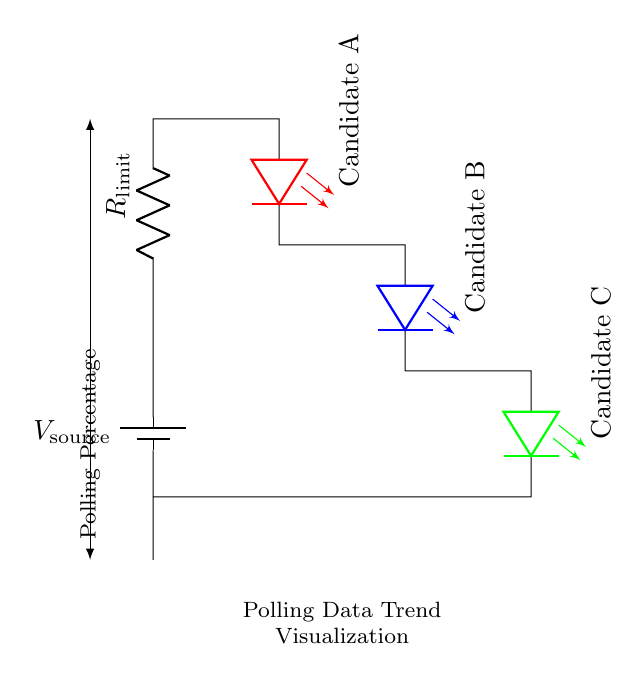What is the total number of LEDs in the circuit? The circuit diagram shows three distinct LEDs labeled as Candidate A, Candidate B, and Candidate C. By counting each LED represented in the diagram, we see a total of three LEDs.
Answer: three What does the resistor in the circuit do? The resistor labeled as R limiting current is present in the circuit for the purpose of preventing excessive current from flowing through the LEDs, which could cause damage. The current limiting resistor is essential in ensuring the LEDs operate safely.
Answer: current limiting What color is the LED representing Candidate B? The LED for Candidate B is colored blue as indicated in the diagram. The circuit clearly shows each LED's color next to its label.
Answer: blue How many components are connected in series before returning to the battery? The components in series before returning to the battery include the current limiting resistor and all three LEDs, amounting to four components in total when counted together. Thus, there are four components in this series connection.
Answer: four What is the purpose of the battery in this circuit? The purpose of the battery labeled as V source is to provide the voltage required to power the entire circuit, which allows the LEDs to illuminate based on the input from the polling data. It is the source of electrical energy for the system.
Answer: power source If Candidate C has the highest polling percentage, which LED would be the brightest? Given that candidate C has the highest polling percentage, it will allow the most current through its LED, making it the brightest compared to the others, which would receive less current due to their relative poll performances.
Answer: Candidate C 